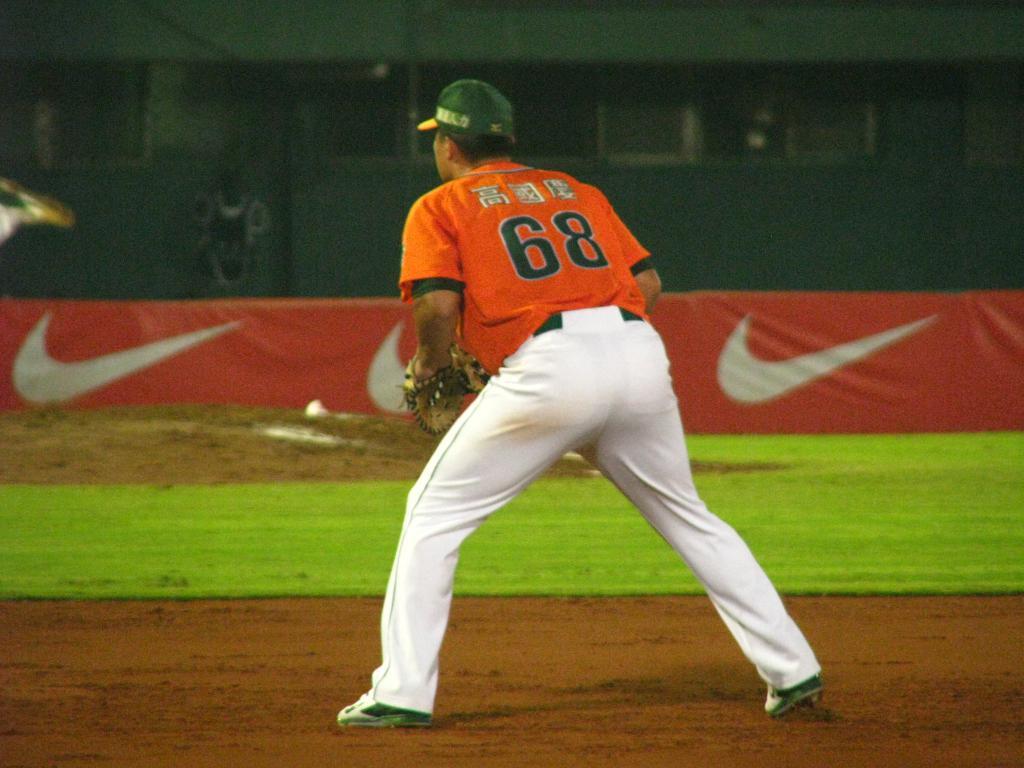What is this player's number?
Offer a terse response. 68. 